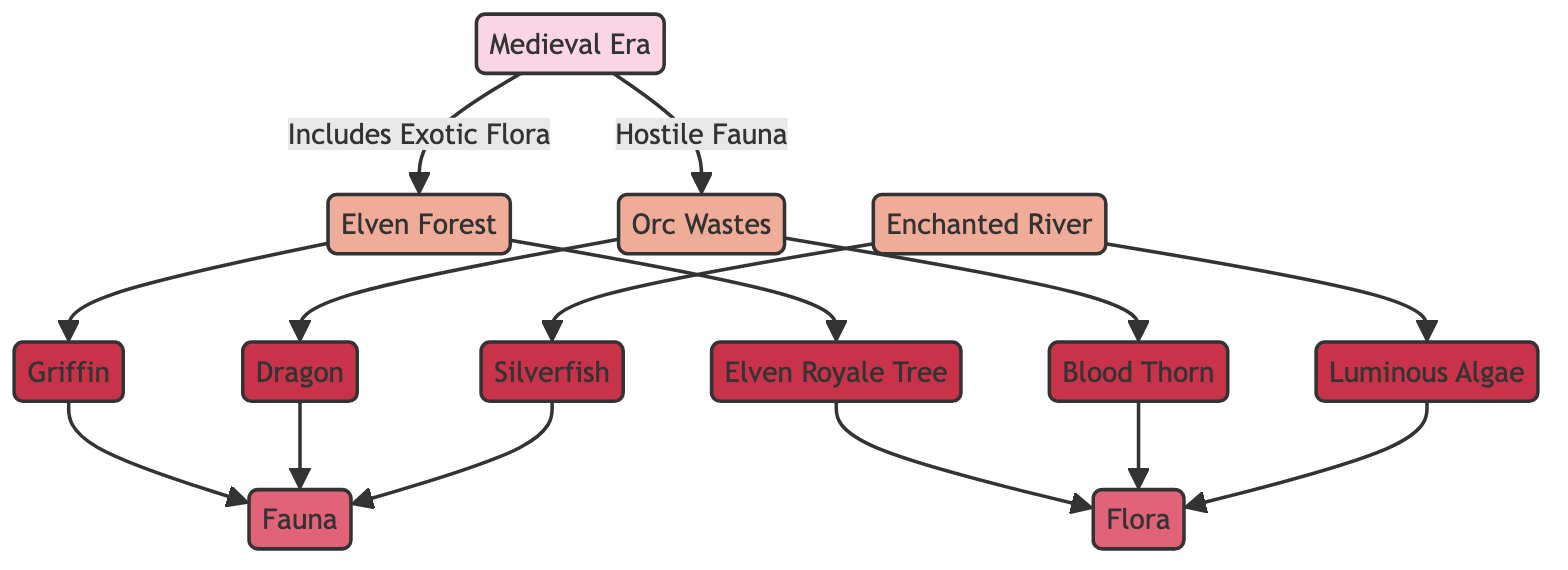What is the main category in the diagram? The diagram organizes its information into two main categories named 'Fauna' and 'Flora'. This can be identified from the 'Fauna' and 'Flora' nodes that branch out from the tree structure representing the ecosystems.
Answer: Fauna and Flora How many biomes are shown in the Medieval Era? The diagram showcases three distinct biomes within the Medieval Era: 'Elven Forest', 'Orc Wastes', and 'Enchanted River'. By counting the unique biome nodes directly connected to the Medieval Era node, we find the total.
Answer: 3 Which species is associated with the Elven Forest? The Elven Forest is associated with two species: the 'Griffin' and the 'Elven Royale Tree'. The connection is visible as both species nodes are directed from the Elven Forest node.
Answer: Griffin and Elven Royale Tree Which biome contains the 'Dragon'? By tracing the pathway from the 'Dragon' species node, it is clear that the Dragon is located within the 'Orc Wastes' biome. This connection is specifically illustrated within the flow structure of the diagram.
Answer: Orc Wastes How many species are connected to the 'Enchanted River'? The 'Enchanted River' biome features two species connected to it: 'Silverfish' and 'Luminous Algae'. Counting the edges from this node allows us to find the total number of connected species.
Answer: 2 Which flora species is considered 'Hostile'? The diagram illustrates that the 'Blood Thorn' species is connected to the 'Orc Wastes', defined as a hostile biome. The relationship between Blood Thorn and Orc Wastes indicates its hostile nature.
Answer: Blood Thorn Identify the relationship between 'Griffin' and 'Fauna'. The diagram exhibits a direct connection from the 'Griffin' species node to the 'Fauna' category, illustrating that it falls under that biological classification.
Answer: Is a member of What do the species 'Silverfish' and 'Luminous Algae' have in common? Both species are categorized under the 'Fauna' section and originate from the 'Enchanted River' biome, showcasing their ecological relationship in the diagram.
Answer: Both belong to Fauna Which category contains the 'Elven Royale Tree'? The 'Elven Royale Tree' species is included within the 'Flora' category as indicated by its direct connection from that category node.
Answer: Flora 